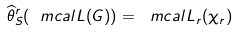<formula> <loc_0><loc_0><loc_500><loc_500>\widehat { \theta } _ { S } ^ { r } ( \ m c a l L ( G ) ) = \ m c a l L _ { r } ( \chi _ { r } )</formula> 